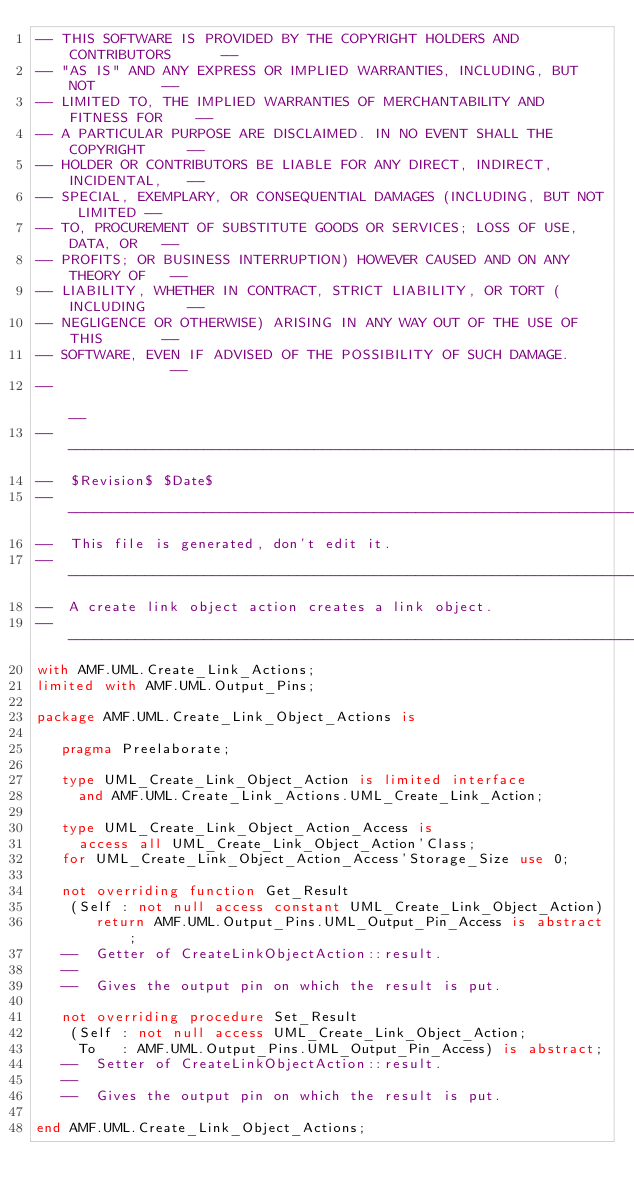<code> <loc_0><loc_0><loc_500><loc_500><_Ada_>-- THIS SOFTWARE IS PROVIDED BY THE COPYRIGHT HOLDERS AND CONTRIBUTORS      --
-- "AS IS" AND ANY EXPRESS OR IMPLIED WARRANTIES, INCLUDING, BUT NOT        --
-- LIMITED TO, THE IMPLIED WARRANTIES OF MERCHANTABILITY AND FITNESS FOR    --
-- A PARTICULAR PURPOSE ARE DISCLAIMED. IN NO EVENT SHALL THE COPYRIGHT     --
-- HOLDER OR CONTRIBUTORS BE LIABLE FOR ANY DIRECT, INDIRECT, INCIDENTAL,   --
-- SPECIAL, EXEMPLARY, OR CONSEQUENTIAL DAMAGES (INCLUDING, BUT NOT LIMITED --
-- TO, PROCUREMENT OF SUBSTITUTE GOODS OR SERVICES; LOSS OF USE, DATA, OR   --
-- PROFITS; OR BUSINESS INTERRUPTION) HOWEVER CAUSED AND ON ANY THEORY OF   --
-- LIABILITY, WHETHER IN CONTRACT, STRICT LIABILITY, OR TORT (INCLUDING     --
-- NEGLIGENCE OR OTHERWISE) ARISING IN ANY WAY OUT OF THE USE OF THIS       --
-- SOFTWARE, EVEN IF ADVISED OF THE POSSIBILITY OF SUCH DAMAGE.             --
--                                                                          --
------------------------------------------------------------------------------
--  $Revision$ $Date$
------------------------------------------------------------------------------
--  This file is generated, don't edit it.
------------------------------------------------------------------------------
--  A create link object action creates a link object.
------------------------------------------------------------------------------
with AMF.UML.Create_Link_Actions;
limited with AMF.UML.Output_Pins;

package AMF.UML.Create_Link_Object_Actions is

   pragma Preelaborate;

   type UML_Create_Link_Object_Action is limited interface
     and AMF.UML.Create_Link_Actions.UML_Create_Link_Action;

   type UML_Create_Link_Object_Action_Access is
     access all UML_Create_Link_Object_Action'Class;
   for UML_Create_Link_Object_Action_Access'Storage_Size use 0;

   not overriding function Get_Result
    (Self : not null access constant UML_Create_Link_Object_Action)
       return AMF.UML.Output_Pins.UML_Output_Pin_Access is abstract;
   --  Getter of CreateLinkObjectAction::result.
   --
   --  Gives the output pin on which the result is put.

   not overriding procedure Set_Result
    (Self : not null access UML_Create_Link_Object_Action;
     To   : AMF.UML.Output_Pins.UML_Output_Pin_Access) is abstract;
   --  Setter of CreateLinkObjectAction::result.
   --
   --  Gives the output pin on which the result is put.

end AMF.UML.Create_Link_Object_Actions;
</code> 